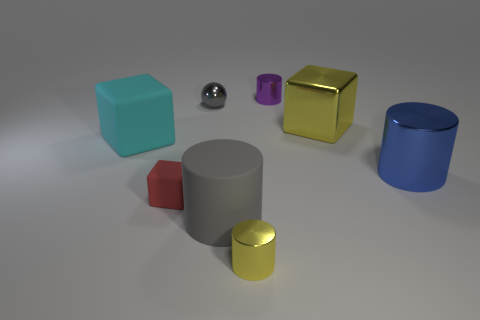Subtract all brown cylinders. Subtract all green balls. How many cylinders are left? 4 Add 1 metal blocks. How many objects exist? 9 Subtract all cubes. How many objects are left? 5 Add 6 blue shiny cylinders. How many blue shiny cylinders exist? 7 Subtract 0 yellow balls. How many objects are left? 8 Subtract all small purple objects. Subtract all large cyan rubber cubes. How many objects are left? 6 Add 7 blue cylinders. How many blue cylinders are left? 8 